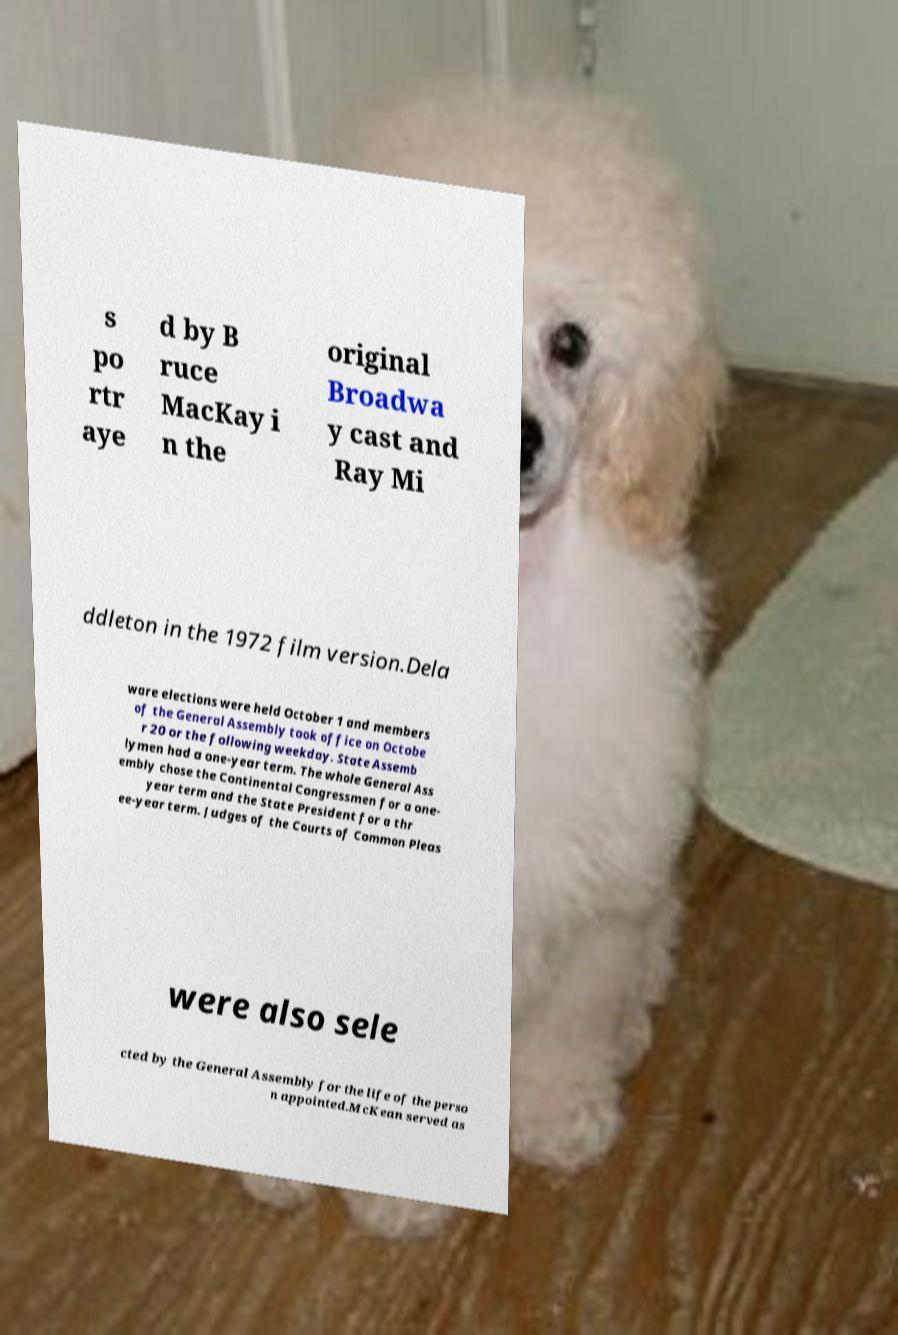Please read and relay the text visible in this image. What does it say? s po rtr aye d by B ruce MacKay i n the original Broadwa y cast and Ray Mi ddleton in the 1972 film version.Dela ware elections were held October 1 and members of the General Assembly took office on Octobe r 20 or the following weekday. State Assemb lymen had a one-year term. The whole General Ass embly chose the Continental Congressmen for a one- year term and the State President for a thr ee-year term. Judges of the Courts of Common Pleas were also sele cted by the General Assembly for the life of the perso n appointed.McKean served as 